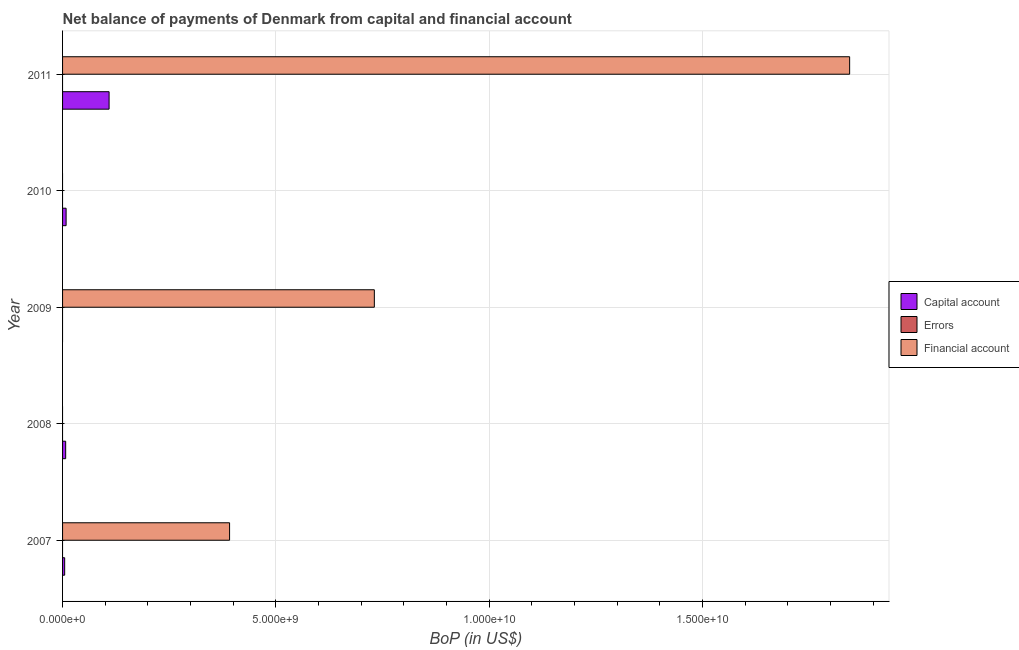Are the number of bars per tick equal to the number of legend labels?
Your answer should be very brief. No. How many bars are there on the 2nd tick from the top?
Your response must be concise. 1. What is the label of the 3rd group of bars from the top?
Provide a short and direct response. 2009. Across all years, what is the maximum amount of net capital account?
Provide a short and direct response. 1.09e+09. Across all years, what is the minimum amount of errors?
Your response must be concise. 0. What is the total amount of errors in the graph?
Offer a terse response. 0. What is the difference between the amount of financial account in 2009 and that in 2011?
Provide a short and direct response. -1.11e+1. What is the difference between the amount of net capital account in 2011 and the amount of financial account in 2009?
Keep it short and to the point. -6.22e+09. What is the average amount of financial account per year?
Keep it short and to the point. 5.93e+09. In the year 2007, what is the difference between the amount of net capital account and amount of financial account?
Give a very brief answer. -3.86e+09. What is the ratio of the amount of financial account in 2009 to that in 2011?
Make the answer very short. 0.4. Is the amount of financial account in 2007 less than that in 2011?
Your answer should be compact. Yes. What is the difference between the highest and the second highest amount of financial account?
Ensure brevity in your answer.  1.11e+1. What is the difference between the highest and the lowest amount of financial account?
Keep it short and to the point. 1.84e+1. In how many years, is the amount of errors greater than the average amount of errors taken over all years?
Provide a short and direct response. 0. Is the sum of the amount of financial account in 2007 and 2009 greater than the maximum amount of net capital account across all years?
Offer a very short reply. Yes. Are all the bars in the graph horizontal?
Provide a short and direct response. Yes. How many years are there in the graph?
Your answer should be compact. 5. What is the difference between two consecutive major ticks on the X-axis?
Your answer should be very brief. 5.00e+09. Are the values on the major ticks of X-axis written in scientific E-notation?
Ensure brevity in your answer.  Yes. Does the graph contain any zero values?
Provide a short and direct response. Yes. Where does the legend appear in the graph?
Your answer should be compact. Center right. How are the legend labels stacked?
Provide a succinct answer. Vertical. What is the title of the graph?
Provide a succinct answer. Net balance of payments of Denmark from capital and financial account. Does "Labor Market" appear as one of the legend labels in the graph?
Your answer should be compact. No. What is the label or title of the X-axis?
Your response must be concise. BoP (in US$). What is the label or title of the Y-axis?
Provide a succinct answer. Year. What is the BoP (in US$) of Capital account in 2007?
Give a very brief answer. 4.93e+07. What is the BoP (in US$) in Financial account in 2007?
Ensure brevity in your answer.  3.91e+09. What is the BoP (in US$) of Capital account in 2008?
Your answer should be very brief. 7.29e+07. What is the BoP (in US$) in Errors in 2008?
Provide a short and direct response. 0. What is the BoP (in US$) of Errors in 2009?
Offer a very short reply. 0. What is the BoP (in US$) in Financial account in 2009?
Your answer should be compact. 7.31e+09. What is the BoP (in US$) in Capital account in 2010?
Your answer should be very brief. 8.29e+07. What is the BoP (in US$) in Financial account in 2010?
Provide a short and direct response. 0. What is the BoP (in US$) of Capital account in 2011?
Ensure brevity in your answer.  1.09e+09. What is the BoP (in US$) of Errors in 2011?
Ensure brevity in your answer.  0. What is the BoP (in US$) in Financial account in 2011?
Your response must be concise. 1.84e+1. Across all years, what is the maximum BoP (in US$) in Capital account?
Provide a short and direct response. 1.09e+09. Across all years, what is the maximum BoP (in US$) of Financial account?
Your answer should be very brief. 1.84e+1. Across all years, what is the minimum BoP (in US$) in Financial account?
Provide a succinct answer. 0. What is the total BoP (in US$) in Capital account in the graph?
Ensure brevity in your answer.  1.30e+09. What is the total BoP (in US$) of Errors in the graph?
Provide a short and direct response. 0. What is the total BoP (in US$) of Financial account in the graph?
Keep it short and to the point. 2.97e+1. What is the difference between the BoP (in US$) of Capital account in 2007 and that in 2008?
Provide a succinct answer. -2.35e+07. What is the difference between the BoP (in US$) in Financial account in 2007 and that in 2009?
Provide a succinct answer. -3.39e+09. What is the difference between the BoP (in US$) of Capital account in 2007 and that in 2010?
Your answer should be compact. -3.36e+07. What is the difference between the BoP (in US$) of Capital account in 2007 and that in 2011?
Your answer should be compact. -1.04e+09. What is the difference between the BoP (in US$) of Financial account in 2007 and that in 2011?
Give a very brief answer. -1.45e+1. What is the difference between the BoP (in US$) in Capital account in 2008 and that in 2010?
Your response must be concise. -1.00e+07. What is the difference between the BoP (in US$) in Capital account in 2008 and that in 2011?
Your response must be concise. -1.02e+09. What is the difference between the BoP (in US$) in Financial account in 2009 and that in 2011?
Your answer should be very brief. -1.11e+1. What is the difference between the BoP (in US$) in Capital account in 2010 and that in 2011?
Make the answer very short. -1.01e+09. What is the difference between the BoP (in US$) in Capital account in 2007 and the BoP (in US$) in Financial account in 2009?
Your answer should be compact. -7.26e+09. What is the difference between the BoP (in US$) in Capital account in 2007 and the BoP (in US$) in Financial account in 2011?
Keep it short and to the point. -1.84e+1. What is the difference between the BoP (in US$) of Capital account in 2008 and the BoP (in US$) of Financial account in 2009?
Keep it short and to the point. -7.23e+09. What is the difference between the BoP (in US$) of Capital account in 2008 and the BoP (in US$) of Financial account in 2011?
Your response must be concise. -1.84e+1. What is the difference between the BoP (in US$) in Capital account in 2010 and the BoP (in US$) in Financial account in 2011?
Provide a succinct answer. -1.84e+1. What is the average BoP (in US$) of Capital account per year?
Keep it short and to the point. 2.59e+08. What is the average BoP (in US$) in Financial account per year?
Your answer should be very brief. 5.93e+09. In the year 2007, what is the difference between the BoP (in US$) in Capital account and BoP (in US$) in Financial account?
Offer a very short reply. -3.86e+09. In the year 2011, what is the difference between the BoP (in US$) in Capital account and BoP (in US$) in Financial account?
Offer a very short reply. -1.74e+1. What is the ratio of the BoP (in US$) of Capital account in 2007 to that in 2008?
Ensure brevity in your answer.  0.68. What is the ratio of the BoP (in US$) of Financial account in 2007 to that in 2009?
Provide a short and direct response. 0.54. What is the ratio of the BoP (in US$) of Capital account in 2007 to that in 2010?
Provide a succinct answer. 0.59. What is the ratio of the BoP (in US$) of Capital account in 2007 to that in 2011?
Offer a very short reply. 0.05. What is the ratio of the BoP (in US$) of Financial account in 2007 to that in 2011?
Offer a very short reply. 0.21. What is the ratio of the BoP (in US$) in Capital account in 2008 to that in 2010?
Provide a short and direct response. 0.88. What is the ratio of the BoP (in US$) in Capital account in 2008 to that in 2011?
Make the answer very short. 0.07. What is the ratio of the BoP (in US$) in Financial account in 2009 to that in 2011?
Keep it short and to the point. 0.4. What is the ratio of the BoP (in US$) of Capital account in 2010 to that in 2011?
Provide a short and direct response. 0.08. What is the difference between the highest and the second highest BoP (in US$) in Capital account?
Ensure brevity in your answer.  1.01e+09. What is the difference between the highest and the second highest BoP (in US$) in Financial account?
Provide a succinct answer. 1.11e+1. What is the difference between the highest and the lowest BoP (in US$) in Capital account?
Offer a terse response. 1.09e+09. What is the difference between the highest and the lowest BoP (in US$) in Financial account?
Offer a terse response. 1.84e+1. 